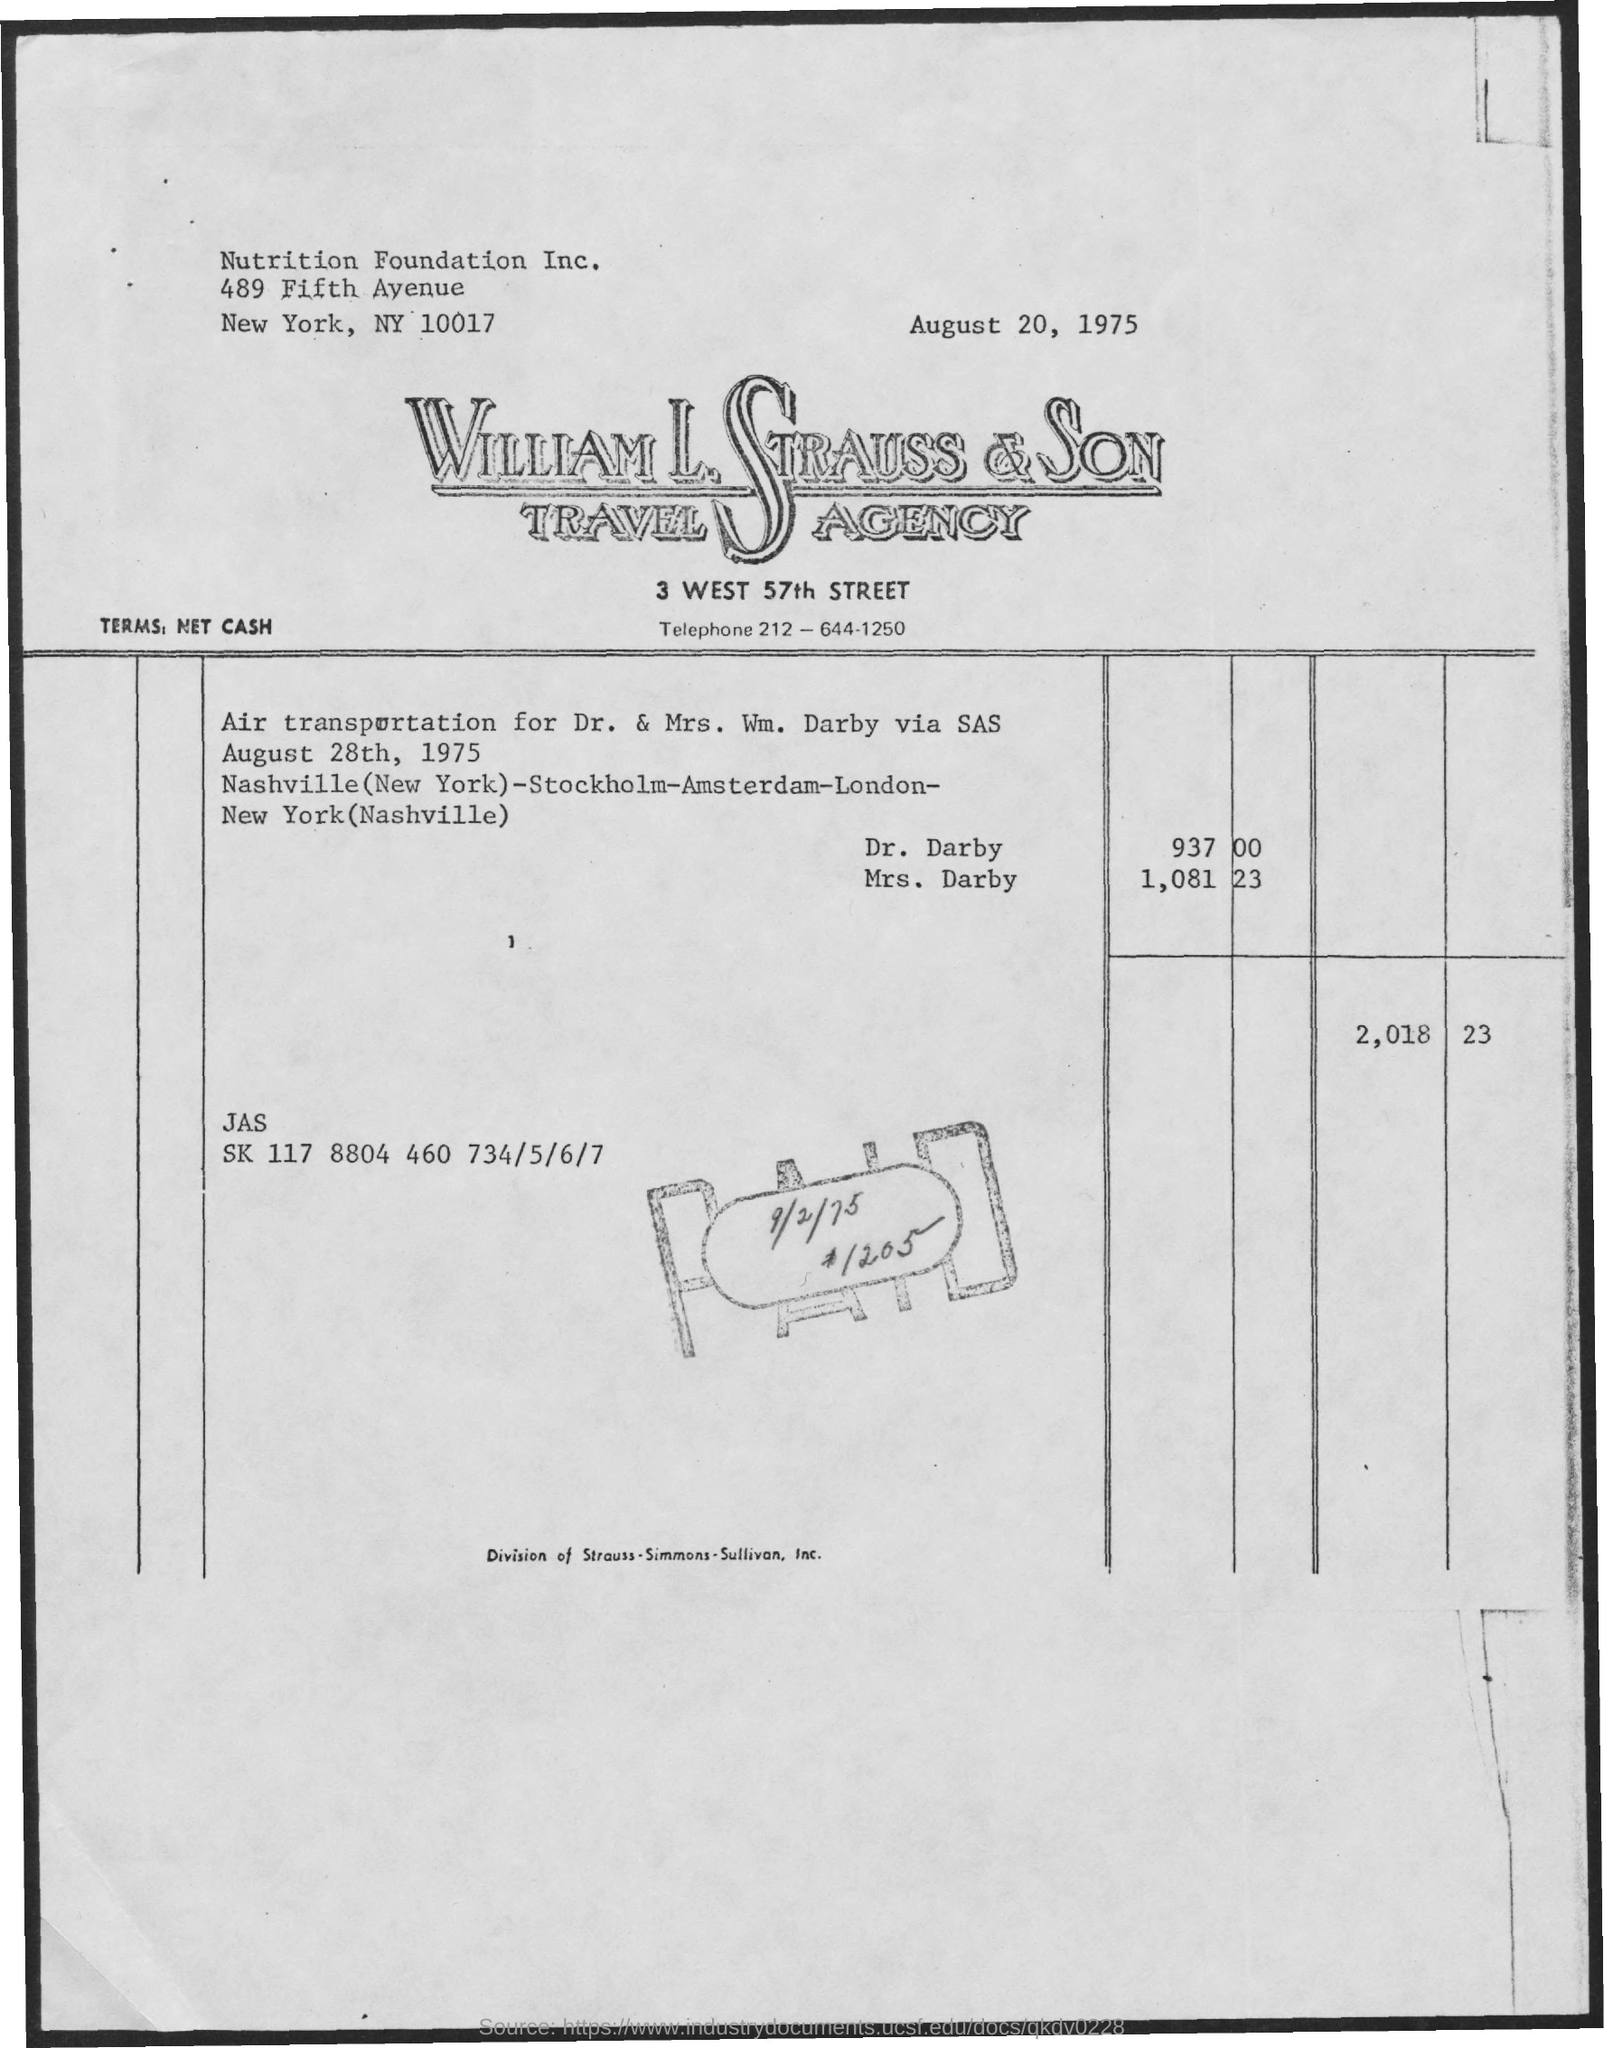What is date  at the top right corner?
Your answer should be compact. August 20, 1975. To which company does this letterhead belong to?
Offer a terse response. William l. strauss & son travel agency. 